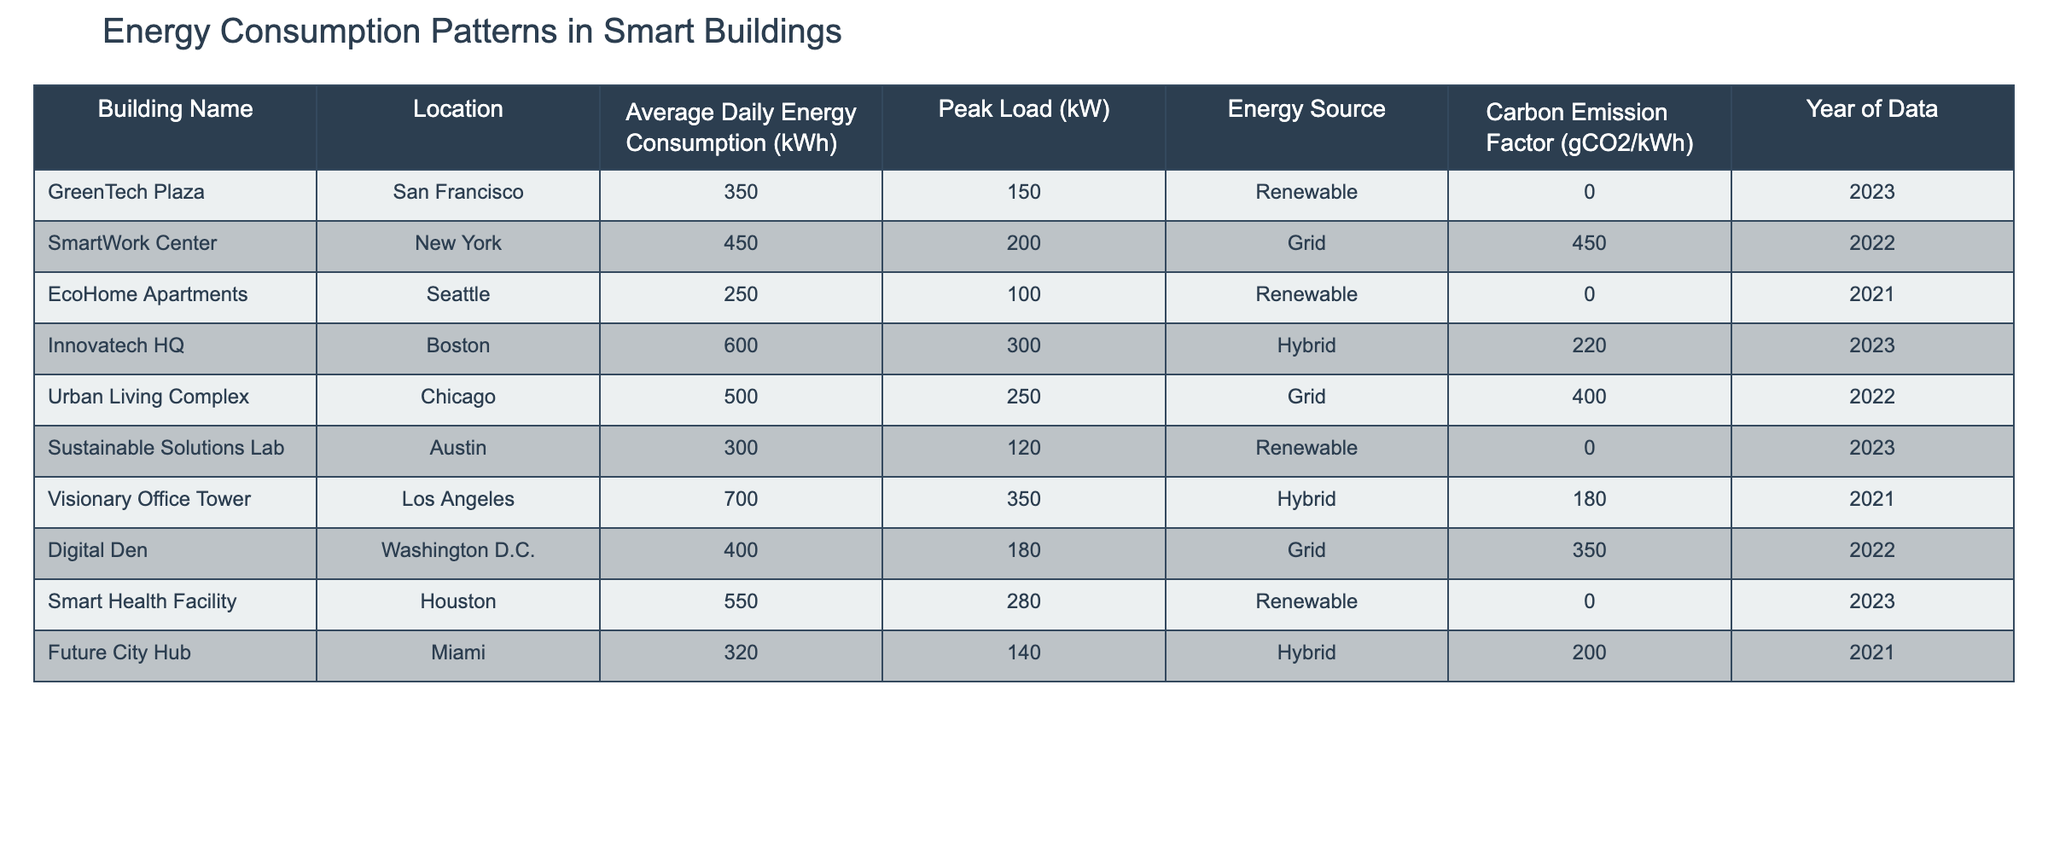What is the average daily energy consumption of the SmartWork Center? The SmartWork Center has an average daily energy consumption listed as 450 kWh. Therefore, the answer is directly taken from the table.
Answer: 450 kWh Which building has the highest peak load? The peak loads are listed as follows: GreenTech Plaza (150 kW), SmartWork Center (200 kW), EcoHome Apartments (100 kW), Innovatech HQ (300 kW), Urban Living Complex (250 kW), Sustainable Solutions Lab (120 kW), Visionary Office Tower (350 kW), Digital Den (180 kW), Smart Health Facility (280 kW), and Future City Hub (140 kW). The highest peak load is from Visionary Office Tower at 350 kW.
Answer: Visionary Office Tower Is the Sustainable Solutions Lab powered by renewable energy? The Energy Source for the Sustainable Solutions Lab is listed as "Renewable," so the answer is yes.
Answer: Yes What is the total average daily energy consumption of buildings powered by the grid? The buildings powered by the grid are: SmartWork Center (450 kWh), Urban Living Complex (500 kWh), and Digital Den (400 kWh). Summing these, we get 450 + 500 + 400 = 1350 kWh. Dividing by 3 (the number of buildings) gives an average of 450 kWh.
Answer: 450 kWh How many buildings have a carbon emission factor of 0 gCO2/kWh? The buildings with a carbon emission factor of 0 are: GreenTech Plaza, EcoHome Apartments, Sustainable Solutions Lab, and Smart Health Facility. Counting these gives us 4 buildings.
Answer: 4 buildings Which city has a building with the lowest average daily energy consumption? The EcoHome Apartments in Seattle have an average daily energy consumption of 250 kWh, which is lower than any other building in the table. We can verify the values of other buildings to confirm this.
Answer: Seattle What is the carbon emission factor of the Innovatech HQ? The Innovatech HQ has a carbon emission factor of 220 gCO2/kWh as listed in the table.
Answer: 220 gCO2/kWh Which building has the highest carbon emission factor among those that use grid energy? Among the buildings using grid energy (SmartWork Center, Urban Living Complex, Digital Den), their carbon emission factors are: 450 gCO2/kWh, 400 gCO2/kWh, and 350 gCO2/kWh respectively. The highest among these is from the SmartWork Center at 450 gCO2/kWh.
Answer: SmartWork Center 